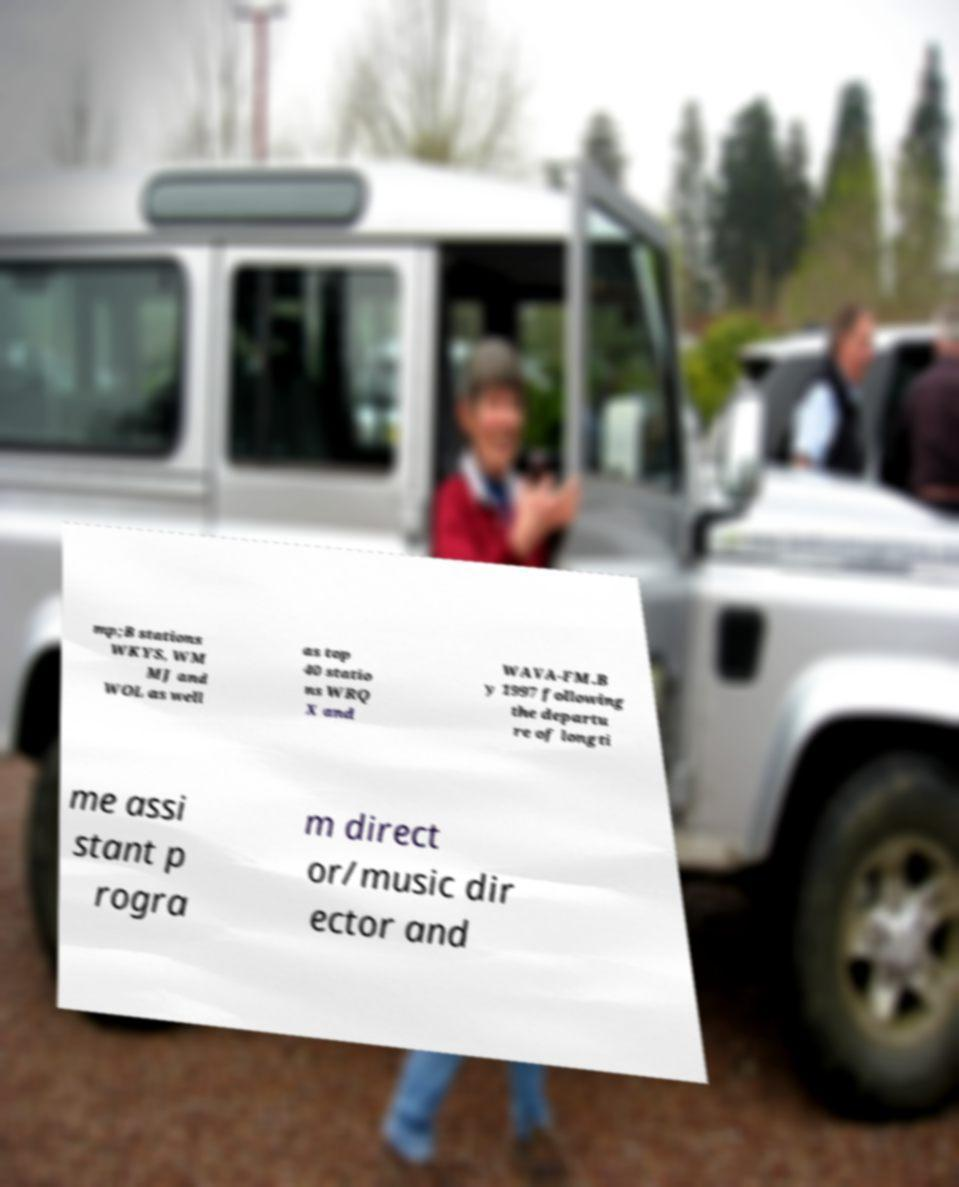Could you extract and type out the text from this image? mp;B stations WKYS, WM MJ and WOL as well as top 40 statio ns WRQ X and WAVA-FM.B y 1997 following the departu re of longti me assi stant p rogra m direct or/music dir ector and 